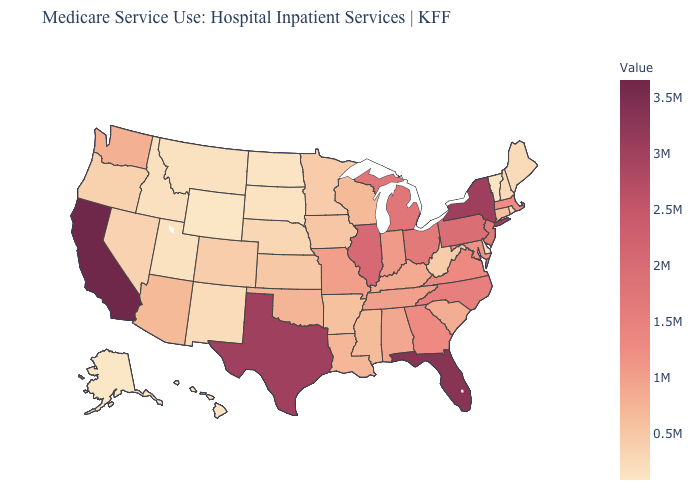Among the states that border Wisconsin , which have the lowest value?
Quick response, please. Minnesota. Does Illinois have a lower value than Virginia?
Quick response, please. No. Does California have the highest value in the USA?
Be succinct. Yes. Does the map have missing data?
Concise answer only. No. Does the map have missing data?
Give a very brief answer. No. Does the map have missing data?
Keep it brief. No. 